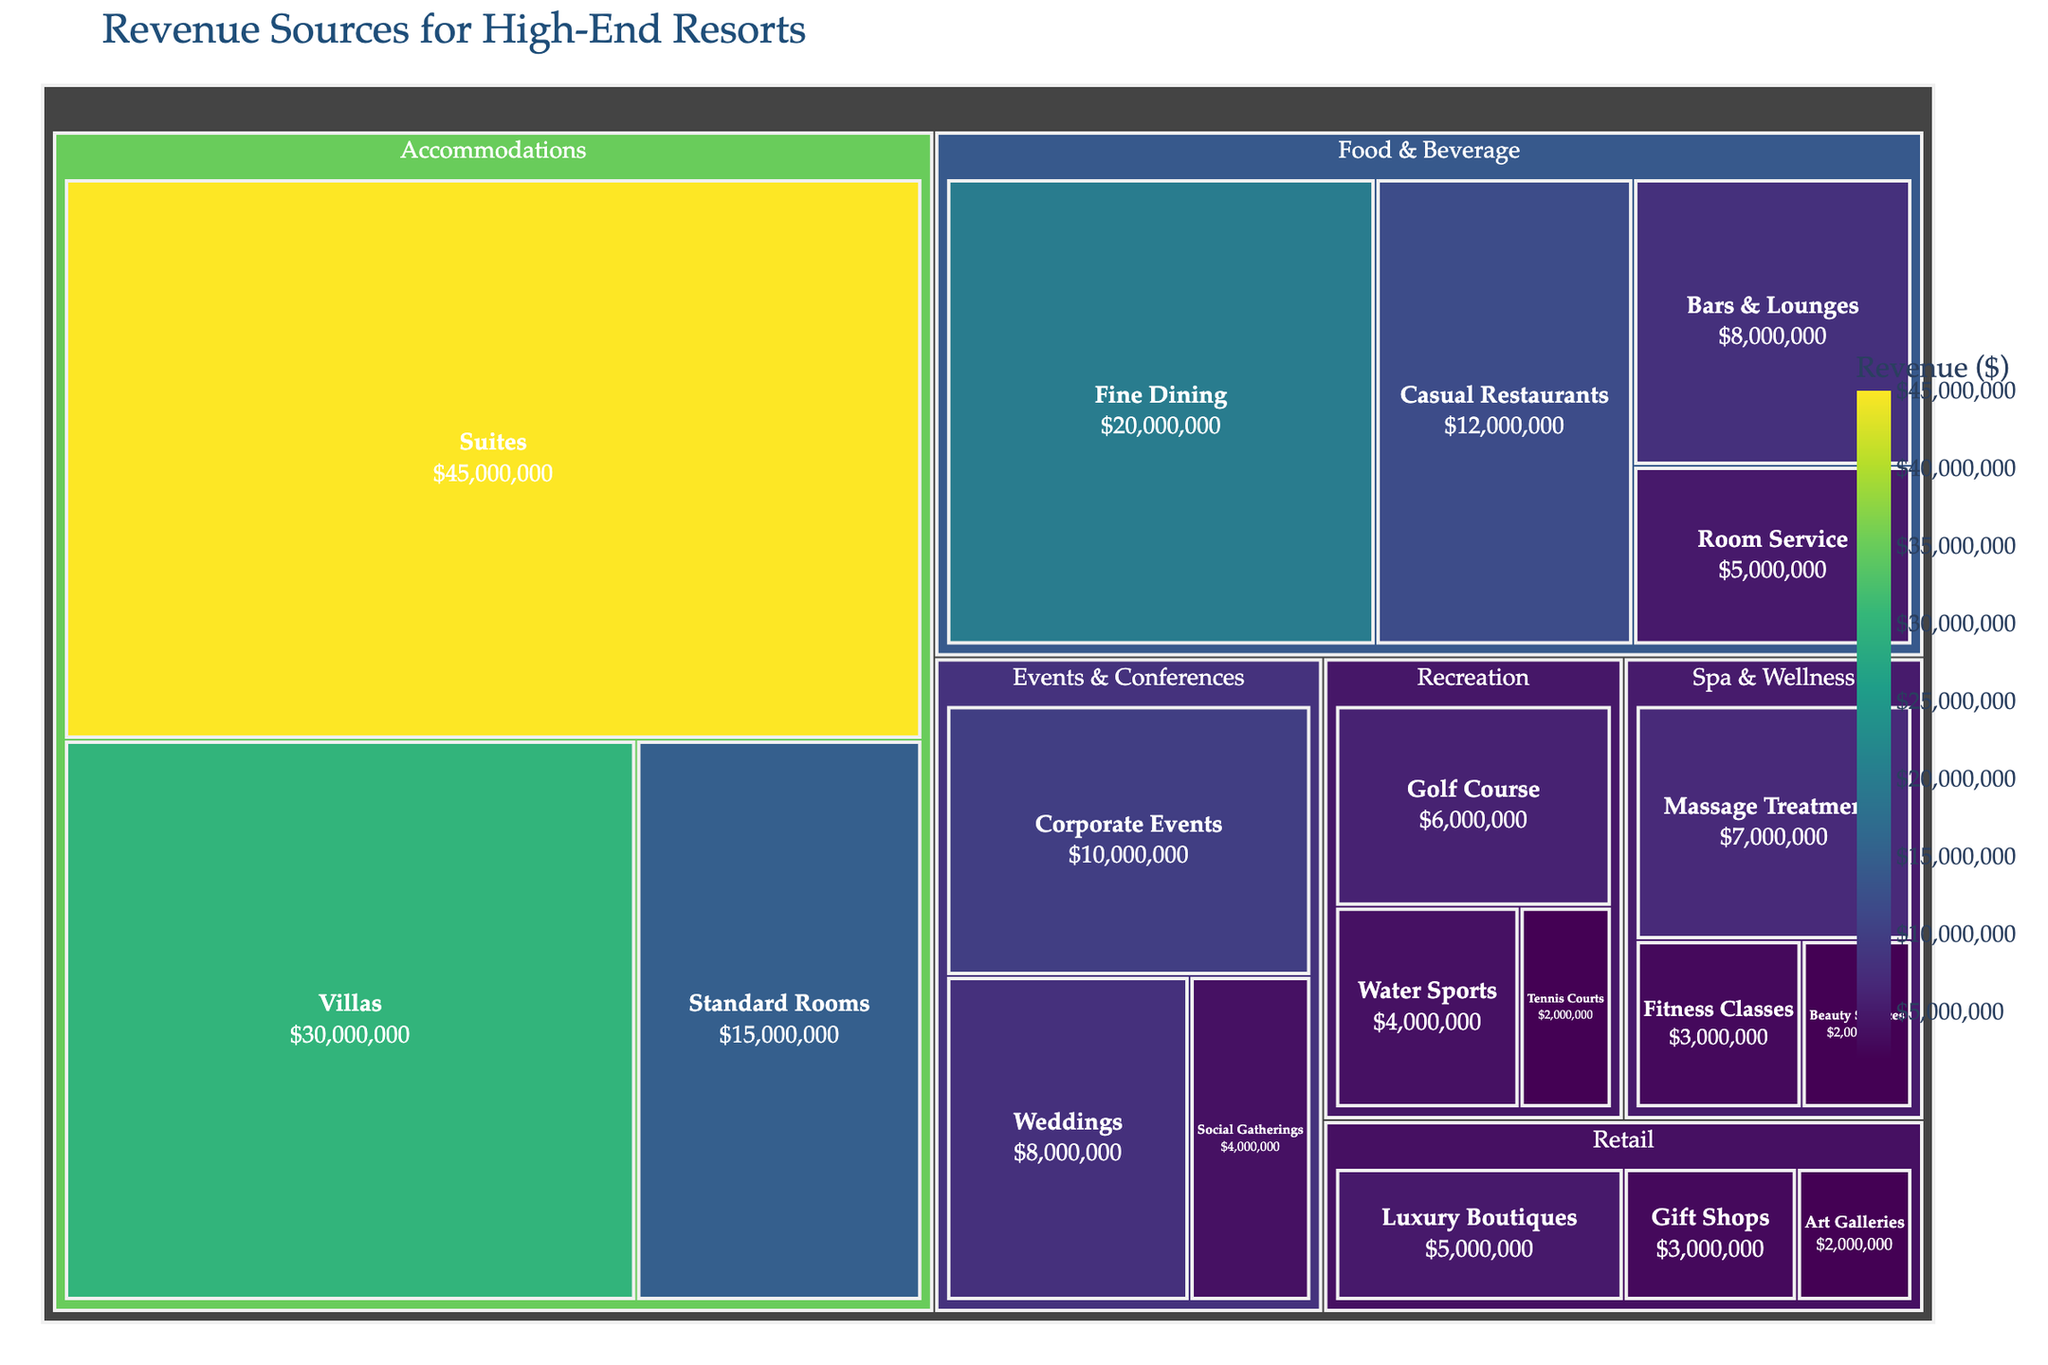What is the title of the treemap? The title of the treemap typically appears at the top of the figure.
Answer: Revenue Sources for High-End Resorts Which subcategory under Accommodations has the highest revenue? By comparing the revenue values of subcategories within Accommodations, we see that Suites has the highest revenue.
Answer: Suites What is the total revenue generated by Food & Beverage? Add the revenue of all subcategories under Food & Beverage: Fine Dining ($20M) + Casual Restaurants ($12M) + Bars & Lounges ($8M) + Room Service ($5M) = $45M.
Answer: $45M Which category has the lowest total revenue? Sum the revenues within each category and compare them: Accommodations ($90M), Food & Beverage ($45M), Spa & Wellness ($12M), Events & Conferences ($22M), Recreation ($12M), Retail ($10M). The lowest is Spa & Wellness tying with Recreation.
Answer: Spa & Wellness and Recreation How does the revenue for Corporate Events compare to Weddings under Events & Conferences? Corporate Events revenue is $10M, Weddings revenue is $8M. Compare the two amounts to see which is higher.
Answer: Corporate Events What is the sum of revenues from Suites, Fine Dining, and Golf Course? Add the revenues: Suites ($45M) + Fine Dining ($20M) + Golf Course ($6M) = $71M.
Answer: $71M Which subcategory has the smallest revenue? Identify and compare all subcategory revenues, the smallest value is found in Fitness Classes and Art Galleries each with $2 million.
Answer: Fitness Classes and Art Galleries What is the average revenue of the subcategories under Retail? Sum the revenues of Retail subcategories and divide by the number of subcategories: ($5M + $3M + $2M) / 3 = $10M / 3 ≈ $3.33M.
Answer: $3.33M What is the difference between the highest and lowest subcategory revenues in Food & Beverage? Calculate the difference: Fine Dining $20M - Room Service $5M = $15M.
Answer: $15M Which subcategory under Recreation generates more revenue than Tennis Courts but less than Golf Course? Identify the revenues: Tennis Courts ($2M), Golf Course ($6M), and Water Sports ($4M). Water Sports fits the criteria.
Answer: Water Sports 